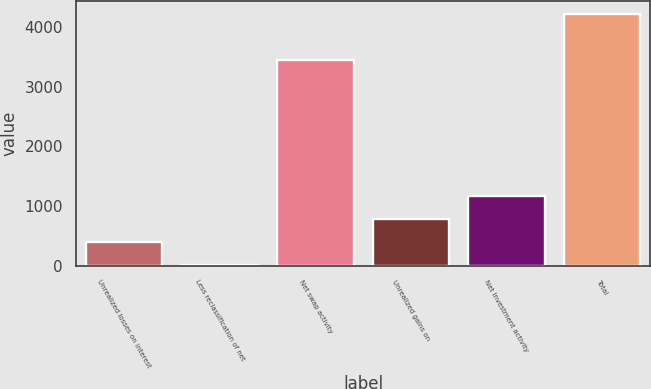Convert chart. <chart><loc_0><loc_0><loc_500><loc_500><bar_chart><fcel>Unrealized losses on interest<fcel>Less reclassification of net<fcel>Net swap activity<fcel>Unrealized gains on<fcel>Net investment activity<fcel>Total<nl><fcel>393.5<fcel>9<fcel>3453<fcel>778<fcel>1162.5<fcel>4222<nl></chart> 